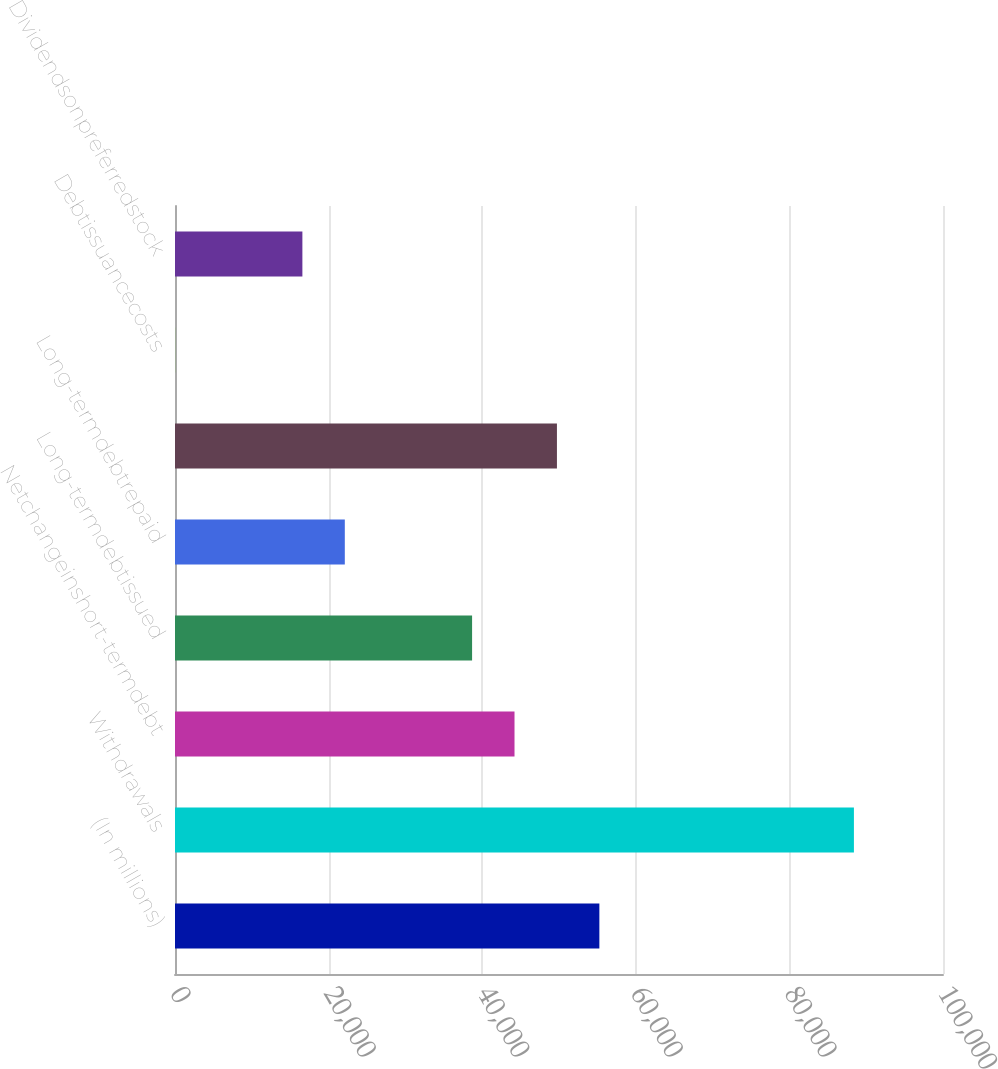<chart> <loc_0><loc_0><loc_500><loc_500><bar_chart><fcel>(In millions)<fcel>Withdrawals<fcel>Netchangeinshort-termdebt<fcel>Long-termdebtissued<fcel>Long-termdebtrepaid<fcel>Unnamed: 5<fcel>Debtissuancecosts<fcel>Dividendsonpreferredstock<nl><fcel>55256<fcel>88401.2<fcel>44207.6<fcel>38683.4<fcel>22110.8<fcel>49731.8<fcel>14<fcel>16586.6<nl></chart> 